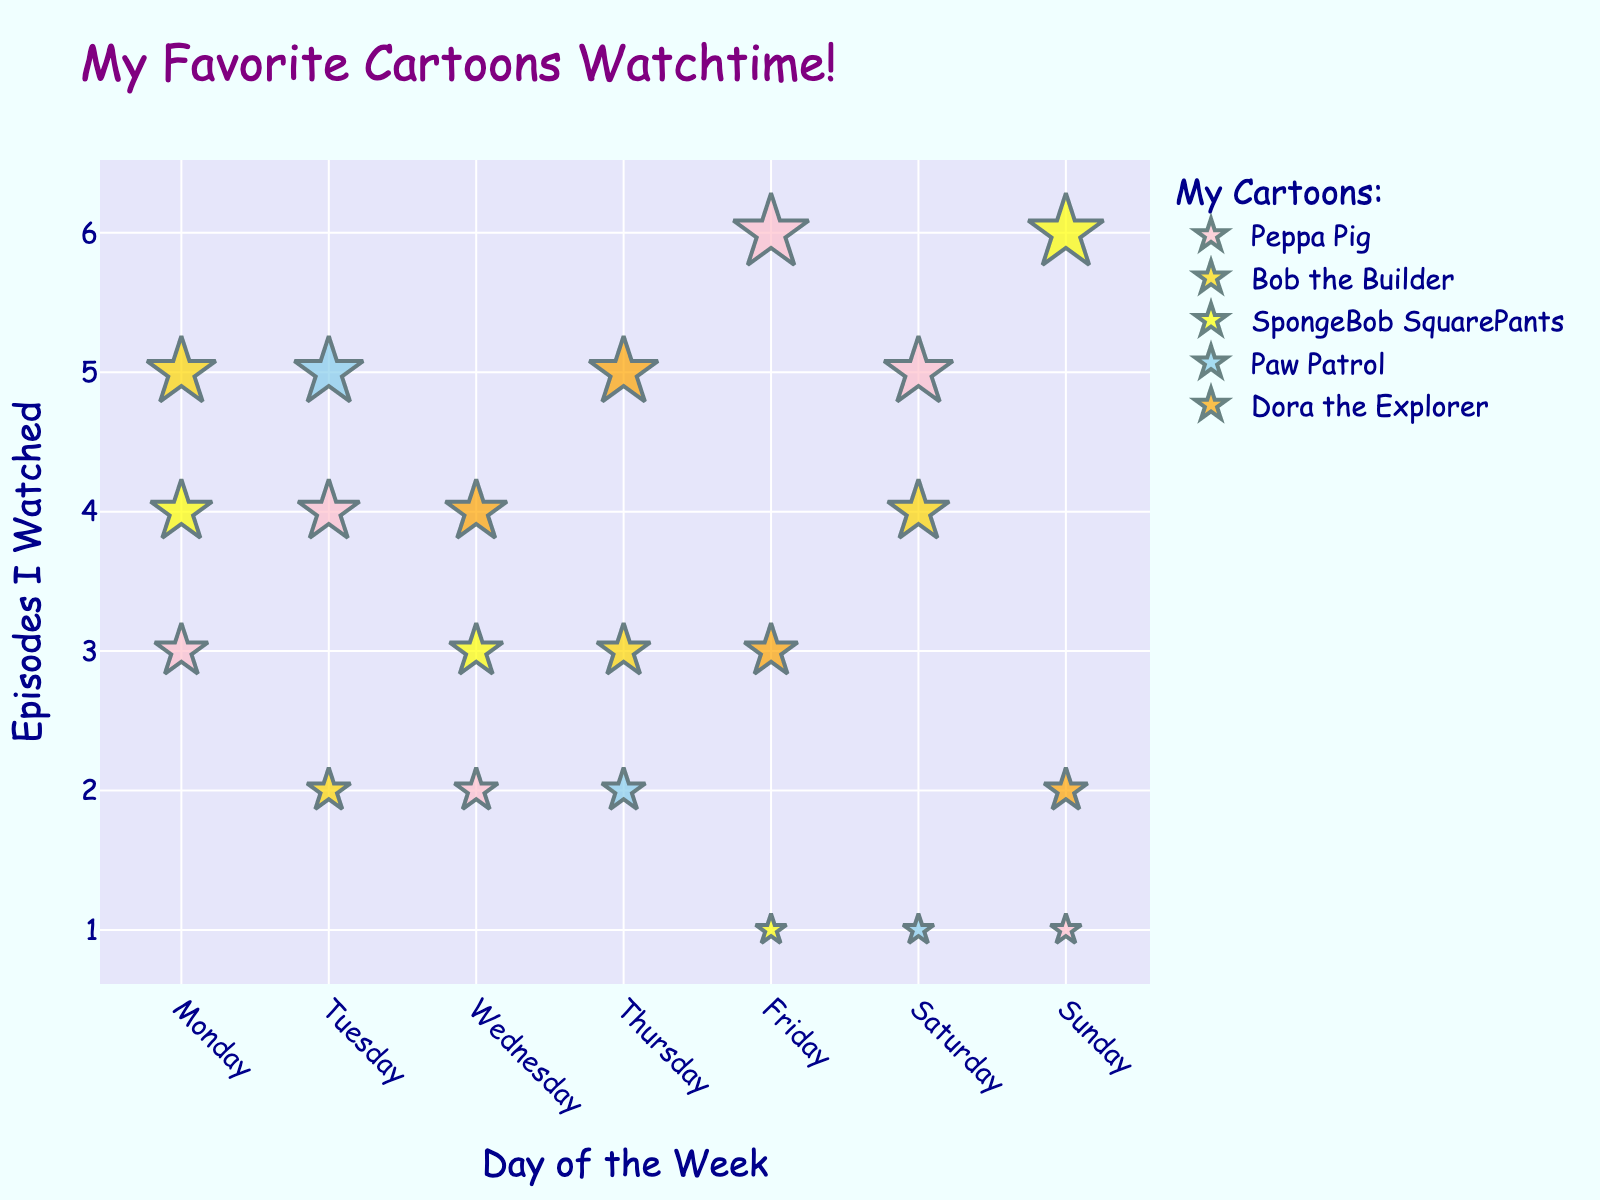Which cartoon had the most episodes watched on Monday? By looking at the points on the scatter plot for Monday and identifying which cartoon has the highest number of episodes watched, you can see that Bob the Builder has the highest frequency.
Answer: Bob the Builder What is the total number of episodes watched for Peppa Pig throughout the week? To find this, add all the episodes of Peppa Pig watched on Monday (3), Tuesday (4), Wednesday (2), Friday (6), Saturday (5), and Sunday (1): 3 + 4 + 2 + 6 + 5 + 1 = 21.
Answer: 21 Which day had the highest frequency of episodes watched for SpongeBob SquarePants? Look for the day with the highest number of episodes watched for SpongeBob SquarePants. The point for SpongeBob on Sunday shows 6 episodes, which is the maximum.
Answer: Sunday Compare the number of episodes of Bob the Builder watched on Monday and Thursday. Which day had more episodes watched, and by how much? Identify the points for Bob the Builder on Monday and Thursday. On Monday, 5 episodes were watched and on Thursday 3 episodes were watched. The difference is 5 - 3 = 2. Monday had 2 more episodes watched than Thursday.
Answer: Monday, by 2 episodes What are the cartoons watched on Wednesday? By examining the data points for Wednesday, we can identify Peppa Pig, SpongeBob SquarePants, and Dora the Explorer as the cartoons watched.
Answer: Peppa Pig, SpongeBob SquarePants, Dora the Explorer On which day was the fewest number of Peppa Pig episodes watched, and how many episodes were watched? By looking at the scatter plot, you can see that the lowest number of episodes for Peppa Pig was watched on Sunday, with 1 episode.
Answer: Sunday, 1 episode How many more episodes of Dora the Explorer were watched on Thursday compared to Sunday? Look at the scatter plot points for Dora the Explorer on Thursday (5 episodes) and Sunday (2 episodes). The difference is 5 - 2 = 3.
Answer: 3 more episodes Which cartoon had episodes watched every weekday? By observing the scatter plot, Peppa Pig has data points for Monday, Tuesday, Wednesday, Thursday, and Friday.
Answer: Peppa Pig What is the average number of episodes watched for Paw Patrol throughout the week? Sum the episodes of Paw Patrol watched on Tuesday (5), Thursday (2), and Saturday (1) and divide by the number of days it was watched: (5 + 2 + 1) / 3 = 2.67.
Answer: 2.67 Looking at the scatter plot, which cartoon had the highest number of episodes watched on Friday? Identify the points for Friday and check which cartoon has the highest number of episodes watched. Peppa Pig has the highest frequency with 6 episodes.
Answer: Peppa Pig 